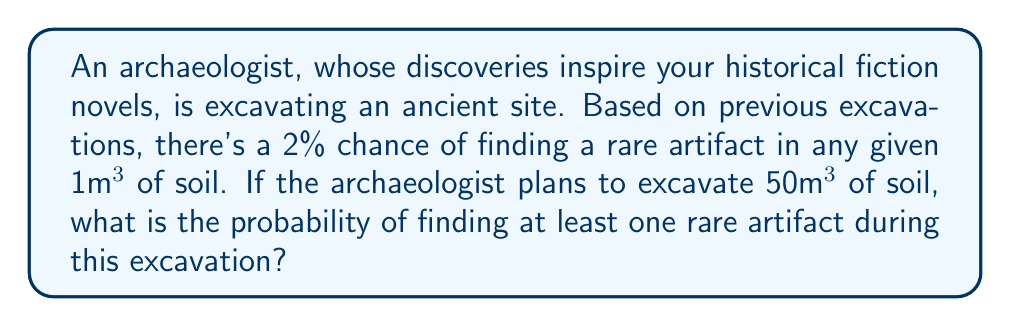Show me your answer to this math problem. To solve this problem, we can use the complement rule of probability. Instead of calculating the probability of finding at least one rare artifact, we'll calculate the probability of finding no rare artifacts and subtract that from 1.

Let's break it down step-by-step:

1) The probability of finding a rare artifact in 1m³ of soil is 2% or 0.02.

2) Therefore, the probability of not finding a rare artifact in 1m³ of soil is:
   $1 - 0.02 = 0.98$

3) For 50m³ of soil, we need to consider each cubic meter independently. The probability of not finding a rare artifact in all 50m³ is:
   $(0.98)^{50}$

4) Now, we can calculate the probability of finding at least one rare artifact by subtracting this from 1:

   $P(\text{at least one rare artifact}) = 1 - P(\text{no rare artifacts})$
   $= 1 - (0.98)^{50}$

5) Let's calculate this:
   $1 - (0.98)^{50} = 1 - 0.3641628...$
   $= 0.6358371...$

6) Converting to a percentage:
   $0.6358371... \times 100\% = 63.58\%$

Therefore, the probability of finding at least one rare artifact during this excavation is approximately 63.58%.
Answer: The probability of finding at least one rare artifact during the excavation is approximately 63.58%. 